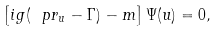<formula> <loc_0><loc_0><loc_500><loc_500>\left [ i g ( { \ p r _ { u } } - \Gamma ) - m \right ] \Psi ( u ) = 0 ,</formula> 